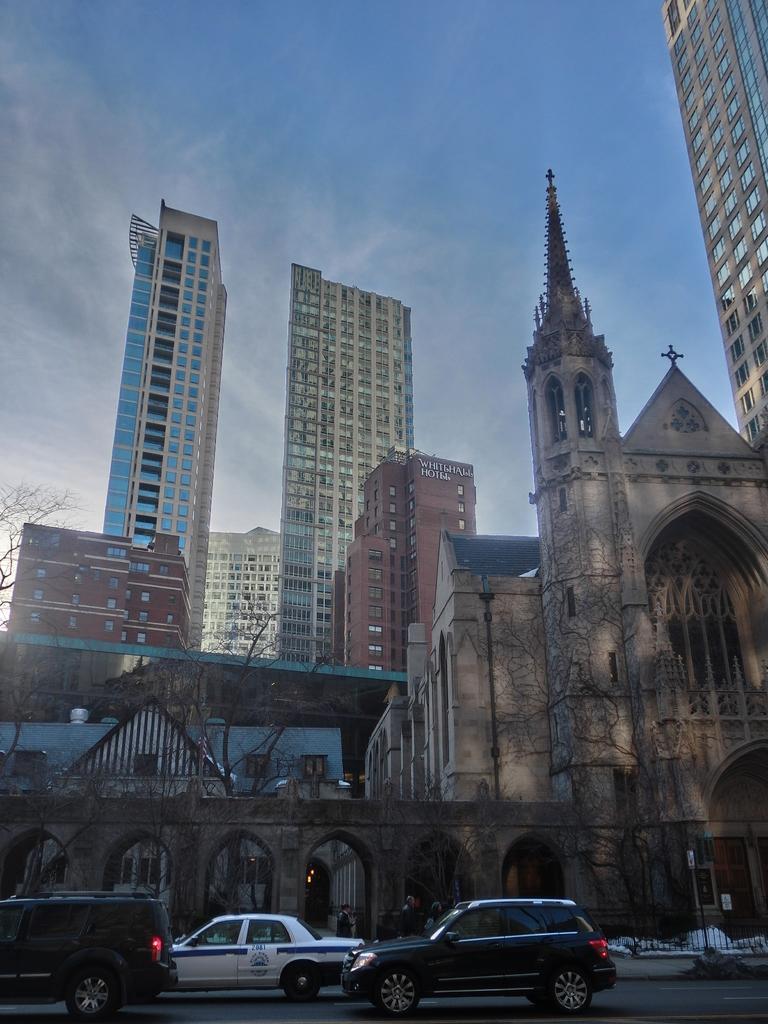Please provide a concise description of this image. In this image there are few buildings. Before it there are few trees. Right side there is a fence. Bottom of the image there are few vehicles on the road. Top of the image there is sky with some clouds. 